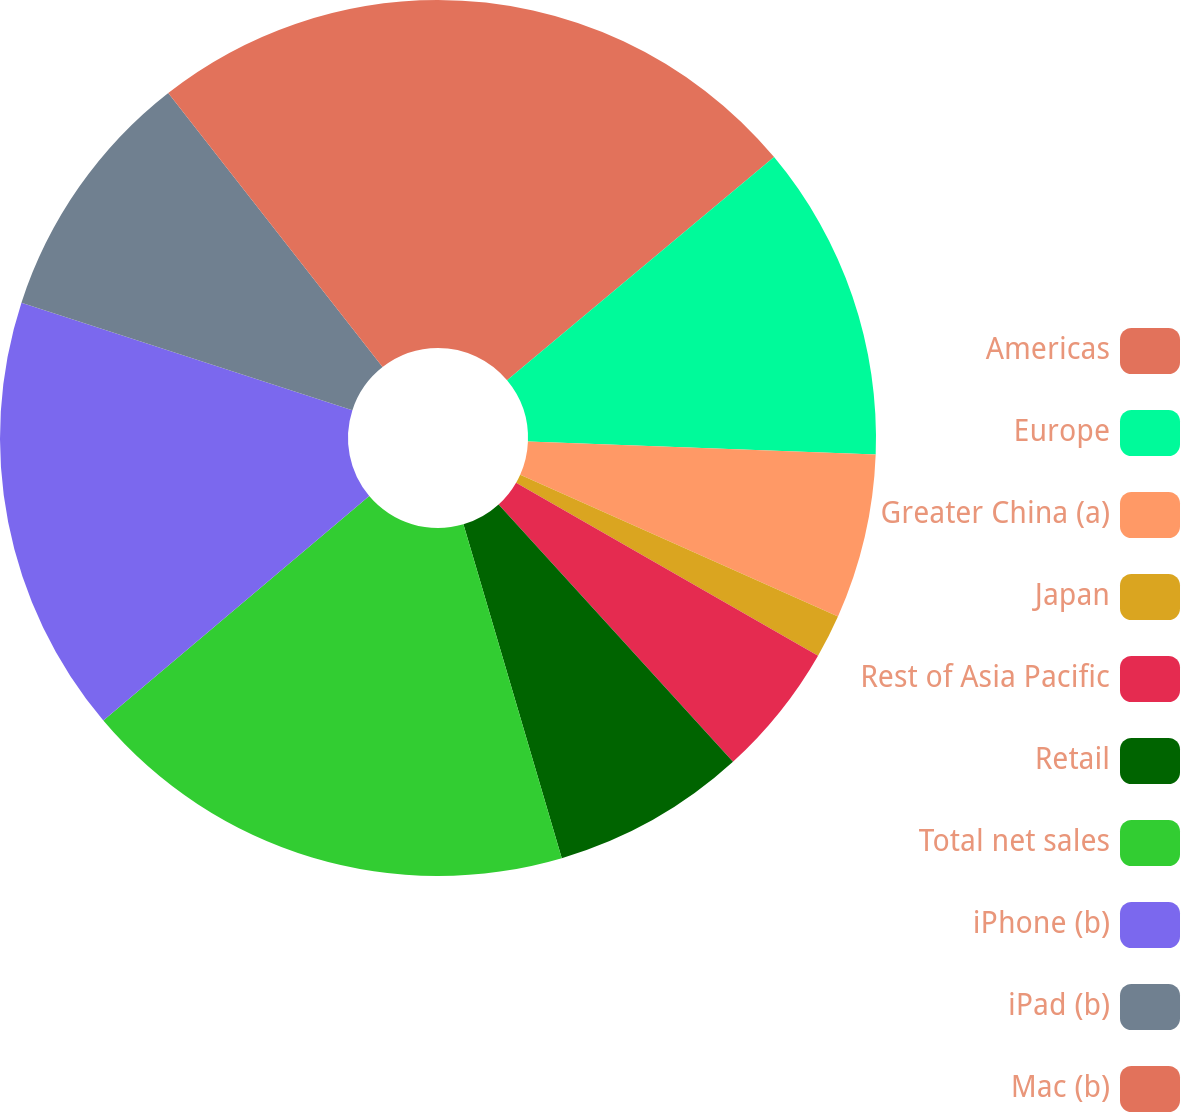<chart> <loc_0><loc_0><loc_500><loc_500><pie_chart><fcel>Americas<fcel>Europe<fcel>Greater China (a)<fcel>Japan<fcel>Rest of Asia Pacific<fcel>Retail<fcel>Total net sales<fcel>iPhone (b)<fcel>iPad (b)<fcel>Mac (b)<nl><fcel>13.92%<fcel>11.68%<fcel>6.08%<fcel>1.6%<fcel>4.96%<fcel>7.2%<fcel>18.4%<fcel>16.16%<fcel>9.44%<fcel>10.56%<nl></chart> 